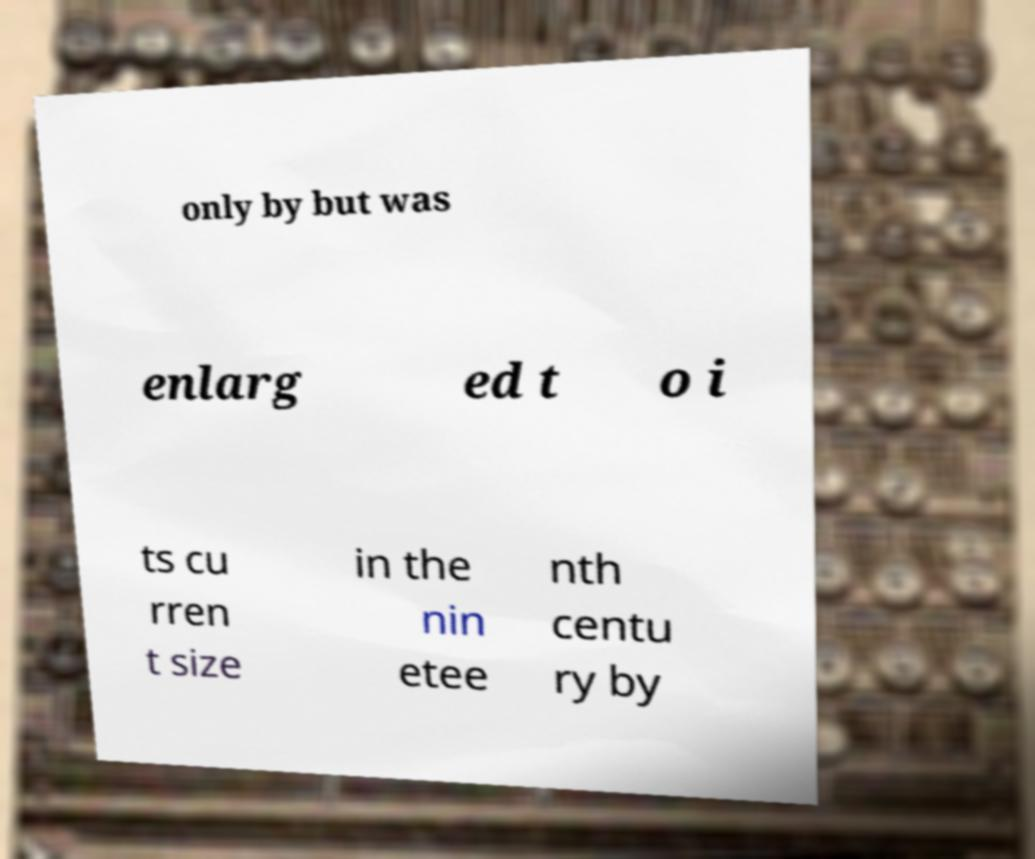Could you extract and type out the text from this image? only by but was enlarg ed t o i ts cu rren t size in the nin etee nth centu ry by 